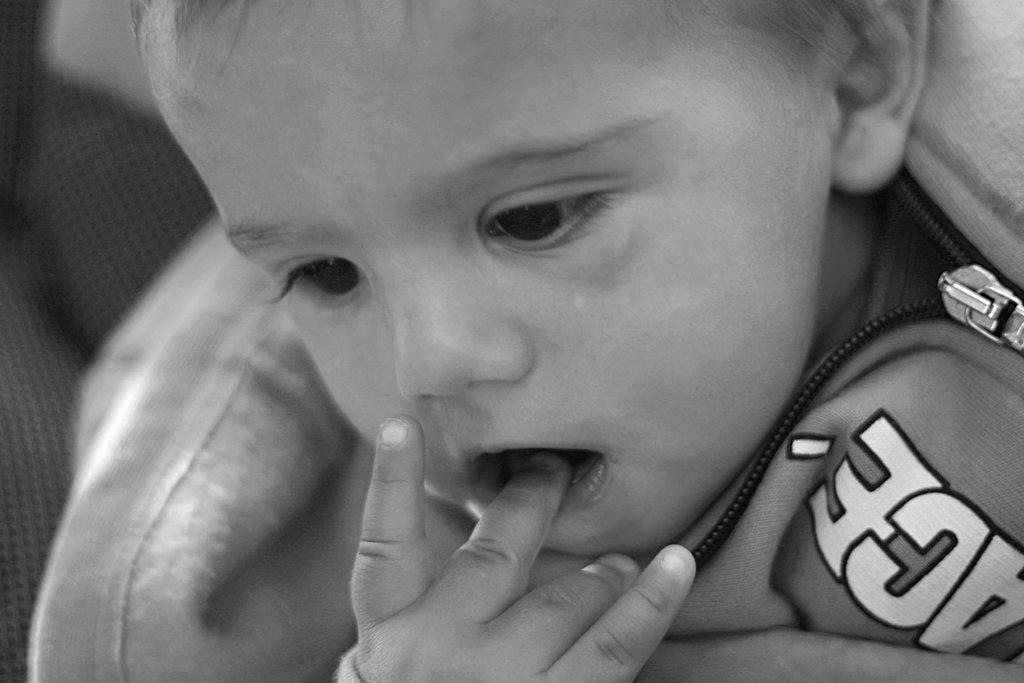What is the main subject of the image? The main subject of the image is a kid. What is the kid doing in the image? The kid is holding his finger with his mouth. What is the color scheme of the image? The image is black and white. What type of bag can be seen in the image? There is no bag present in the image. What kind of waves can be observed in the image? The image is not related to waves or water; it features a kid holding his finger with his mouth. Can you describe the car in the image? There is no car present in the image. 